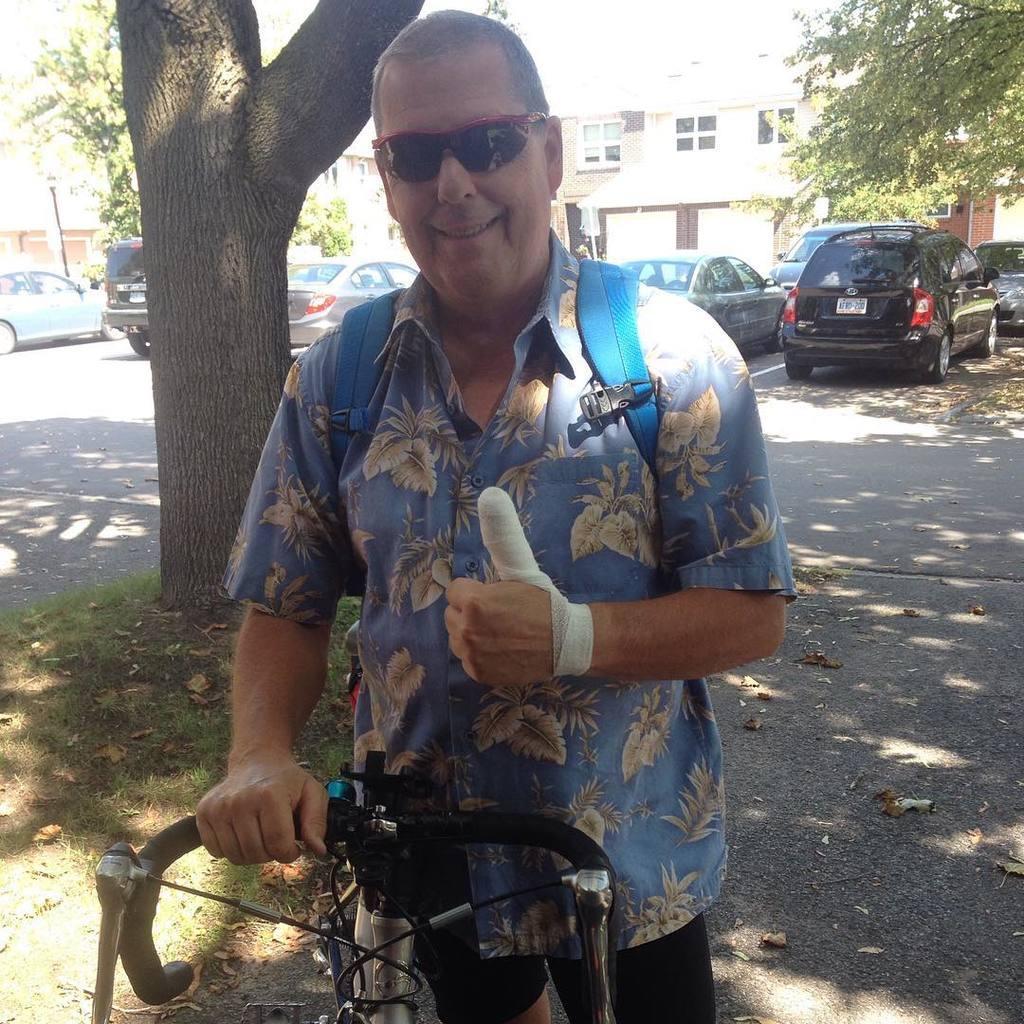Could you give a brief overview of what you see in this image? In this image we can see a man standing on the ground holding a bicycle. On the backside we can see some grass, the bark of a tree, some cars parked on the road, a building with windows, a signboard and some trees. 